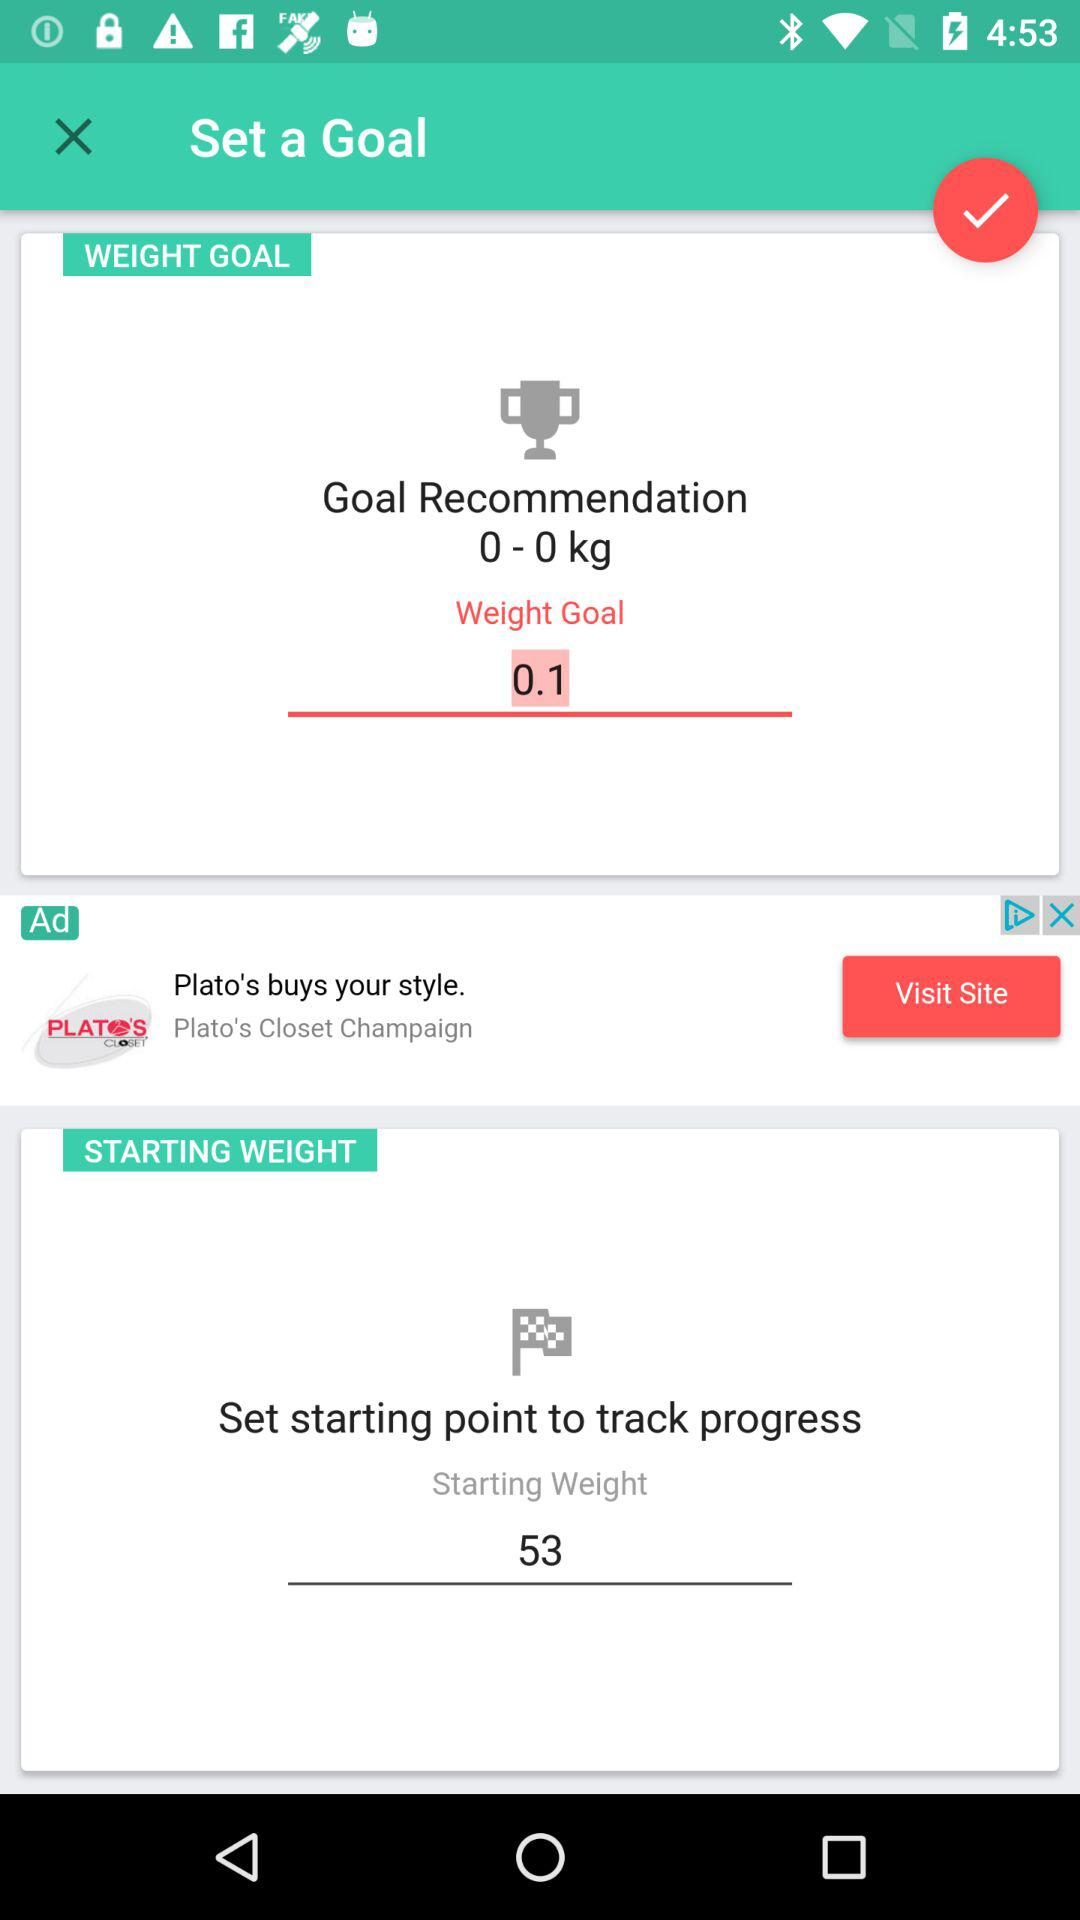What is the "Weight Goal"? The "Weight Goal" is 0.1 kg. 